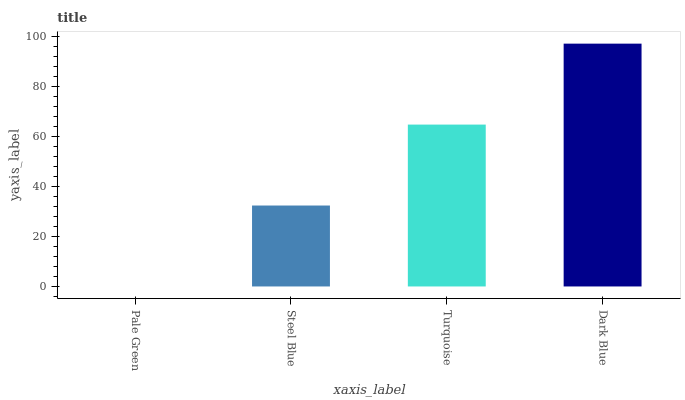Is Pale Green the minimum?
Answer yes or no. Yes. Is Dark Blue the maximum?
Answer yes or no. Yes. Is Steel Blue the minimum?
Answer yes or no. No. Is Steel Blue the maximum?
Answer yes or no. No. Is Steel Blue greater than Pale Green?
Answer yes or no. Yes. Is Pale Green less than Steel Blue?
Answer yes or no. Yes. Is Pale Green greater than Steel Blue?
Answer yes or no. No. Is Steel Blue less than Pale Green?
Answer yes or no. No. Is Turquoise the high median?
Answer yes or no. Yes. Is Steel Blue the low median?
Answer yes or no. Yes. Is Steel Blue the high median?
Answer yes or no. No. Is Dark Blue the low median?
Answer yes or no. No. 